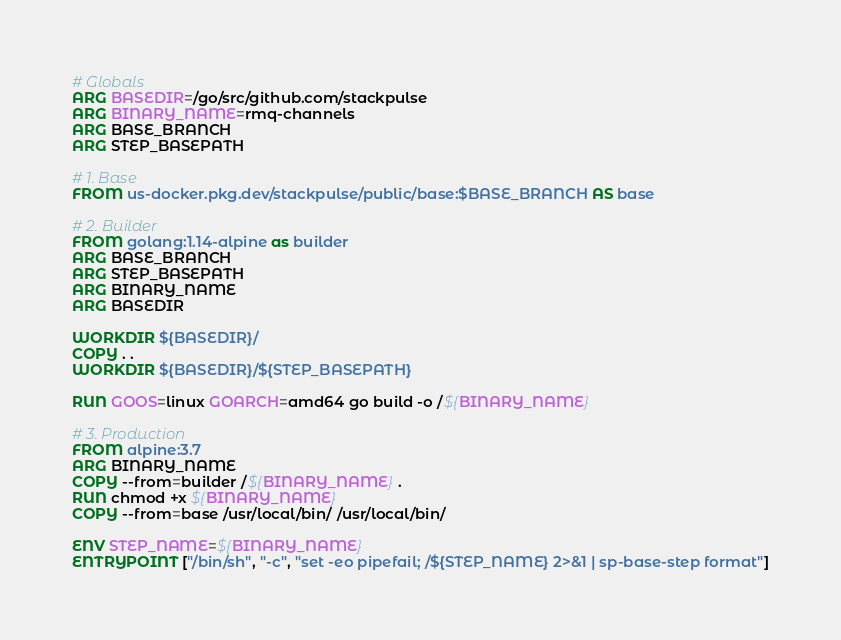Convert code to text. <code><loc_0><loc_0><loc_500><loc_500><_Dockerfile_># Globals
ARG BASEDIR=/go/src/github.com/stackpulse
ARG BINARY_NAME=rmq-channels
ARG BASE_BRANCH
ARG STEP_BASEPATH

# 1. Base
FROM us-docker.pkg.dev/stackpulse/public/base:$BASE_BRANCH AS base

# 2. Builder
FROM golang:1.14-alpine as builder
ARG BASE_BRANCH
ARG STEP_BASEPATH
ARG BINARY_NAME
ARG BASEDIR

WORKDIR ${BASEDIR}/
COPY . .
WORKDIR ${BASEDIR}/${STEP_BASEPATH}

RUN GOOS=linux GOARCH=amd64 go build -o /${BINARY_NAME}

# 3. Production
FROM alpine:3.7
ARG BINARY_NAME
COPY --from=builder /${BINARY_NAME} .
RUN chmod +x ${BINARY_NAME}
COPY --from=base /usr/local/bin/ /usr/local/bin/

ENV STEP_NAME=${BINARY_NAME}
ENTRYPOINT ["/bin/sh", "-c", "set -eo pipefail; /${STEP_NAME} 2>&1 | sp-base-step format"]</code> 